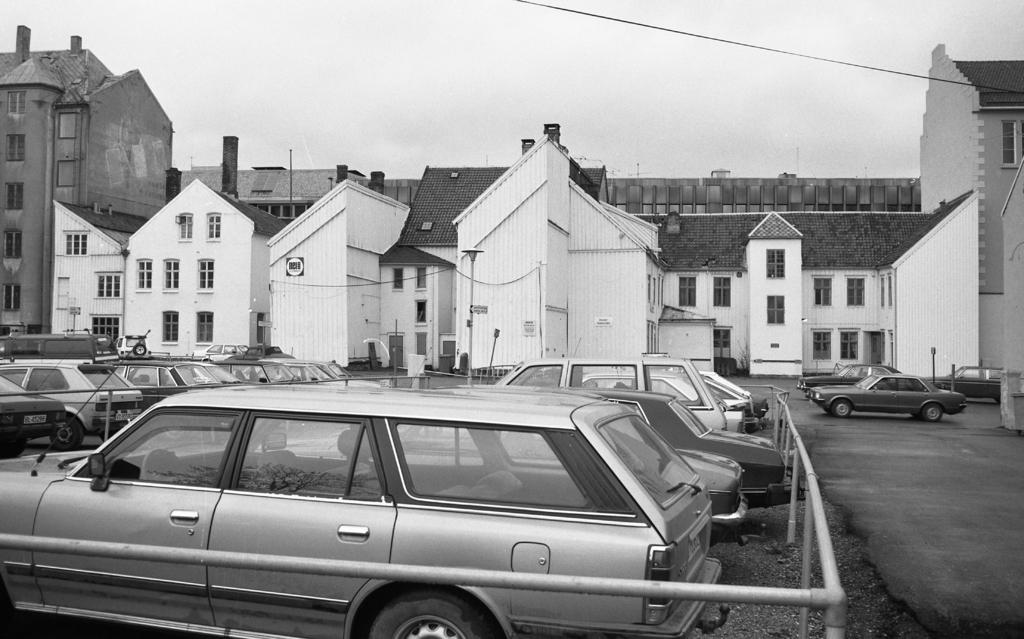What is the color scheme of the image? The image is black and white. Where are the cars located in the image? Some cars are inside a fence, while others are outside on the road. What can be seen in the background of the image? There are buildings in the background. What part of the natural environment is visible in the image? The sky is visible in the image. Reasoning: Let's think step by step by following the steps to produce the conversation. We start by identifying the color scheme of the image, which is black and white. Then, we describe the location of the cars, mentioning that some are inside a fence and others are outside on the road. Next, we observe the background of the image, noting the presence of buildings. Finally, we mention the sky, which is visible in the image. Absurd Question/Answer: What type of hammer is being used by the stranger in the image? A: There is no stranger or hammer present in the image. Can you describe the ball that the stranger is holding in the image? There is no ball or stranger present in the image. 